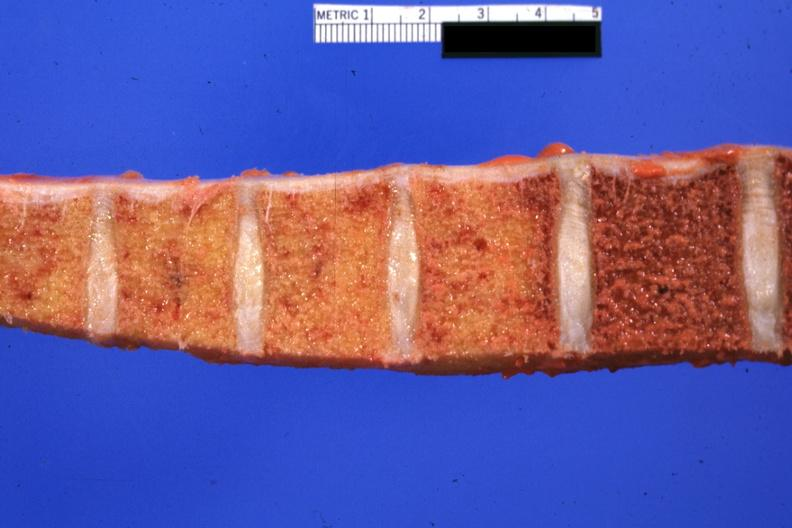why does this image show vertebral column with obvious fibrosis involving four of the bodies but not the remaining one in photo cause of this lesion not proved but almost certainly?
Answer the question using a single word or phrase. Due to radiation for lung carcinoma and meningeal carcinomatosis 